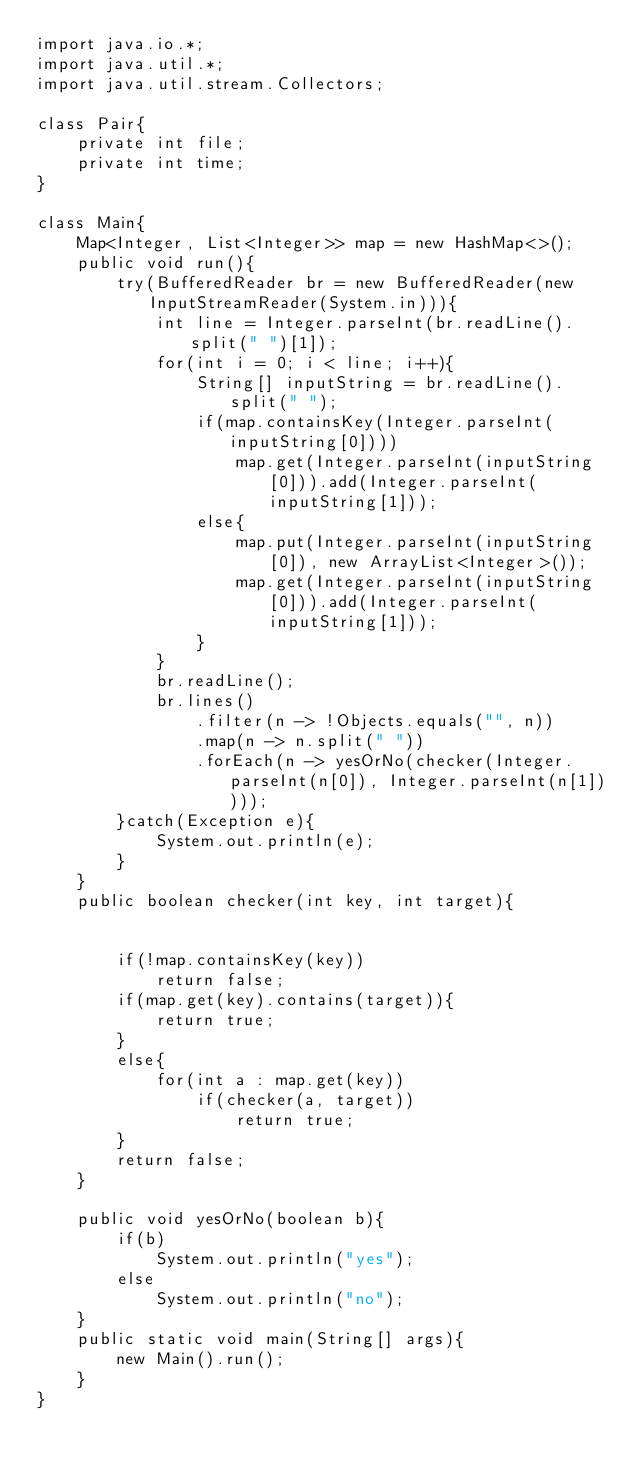Convert code to text. <code><loc_0><loc_0><loc_500><loc_500><_Java_>import java.io.*;
import java.util.*;
import java.util.stream.Collectors;

class Pair{
    private int file;
    private int time;
}

class Main{
    Map<Integer, List<Integer>> map = new HashMap<>();
    public void run(){
        try(BufferedReader br = new BufferedReader(new InputStreamReader(System.in))){
            int line = Integer.parseInt(br.readLine().split(" ")[1]);
            for(int i = 0; i < line; i++){
                String[] inputString = br.readLine().split(" ");
                if(map.containsKey(Integer.parseInt(inputString[0])))
                    map.get(Integer.parseInt(inputString[0])).add(Integer.parseInt(inputString[1]));
                else{
                    map.put(Integer.parseInt(inputString[0]), new ArrayList<Integer>());
                    map.get(Integer.parseInt(inputString[0])).add(Integer.parseInt(inputString[1]));
                }
            }
            br.readLine();
            br.lines()
                .filter(n -> !Objects.equals("", n))
                .map(n -> n.split(" "))
                .forEach(n -> yesOrNo(checker(Integer.parseInt(n[0]), Integer.parseInt(n[1]))));
        }catch(Exception e){
            System.out.println(e);
        }
    }
    public boolean checker(int key, int target){


        if(!map.containsKey(key))
            return false;
        if(map.get(key).contains(target)){
            return true;
        }
        else{
            for(int a : map.get(key))
                if(checker(a, target))
                    return true;
        }
        return false;
    }

    public void yesOrNo(boolean b){
        if(b)
            System.out.println("yes");
        else
            System.out.println("no");
    }
    public static void main(String[] args){
        new Main().run();
    }
}</code> 